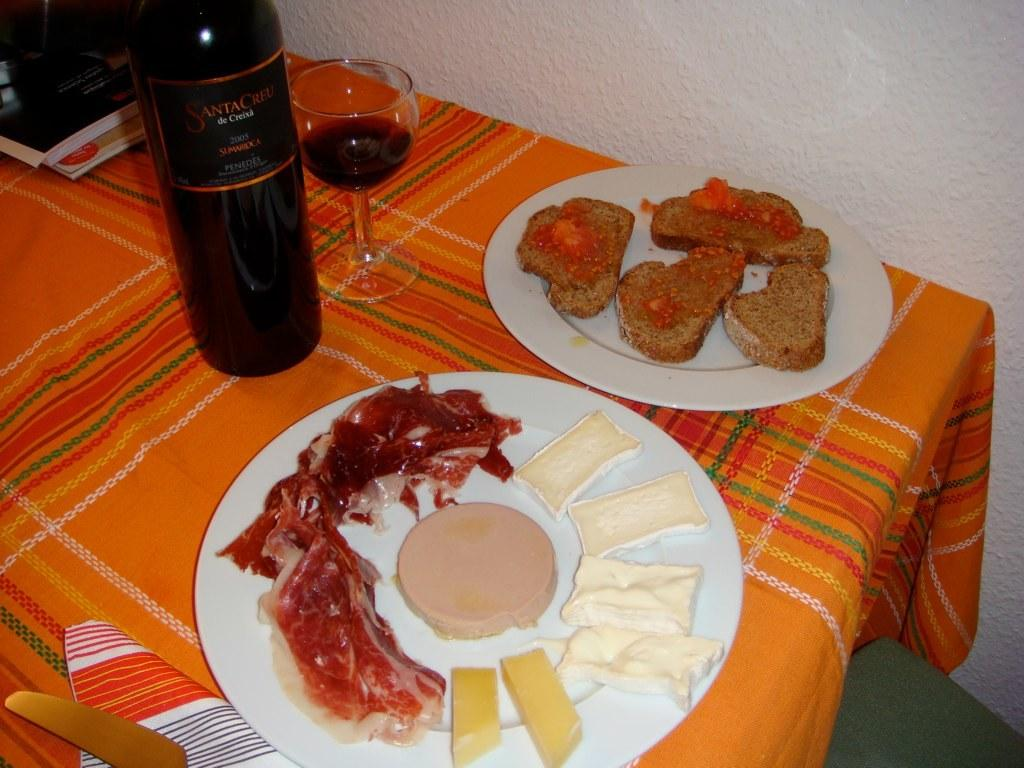<image>
Give a short and clear explanation of the subsequent image. A bottle of 2005 wine sits on an orange tablecloth with some really bad looking food. 